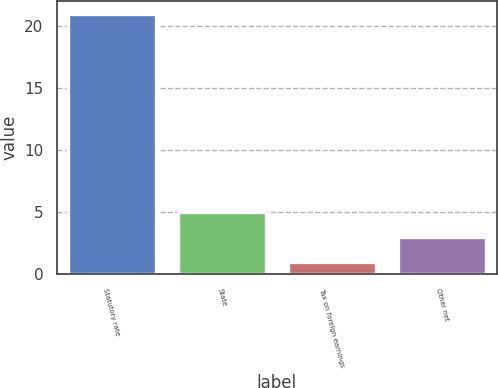Convert chart. <chart><loc_0><loc_0><loc_500><loc_500><bar_chart><fcel>Statutory rate<fcel>State<fcel>Tax on foreign earnings<fcel>Other net<nl><fcel>21<fcel>5<fcel>1<fcel>3<nl></chart> 